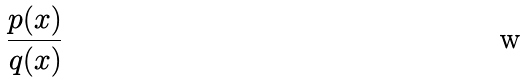<formula> <loc_0><loc_0><loc_500><loc_500>\frac { p ( x ) } { q ( x ) }</formula> 